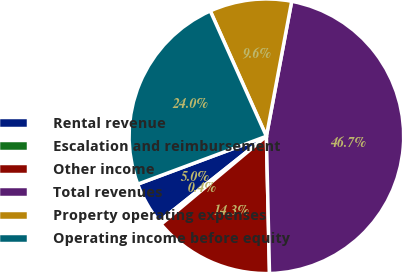Convert chart to OTSL. <chart><loc_0><loc_0><loc_500><loc_500><pie_chart><fcel>Rental revenue<fcel>Escalation and reimbursement<fcel>Other income<fcel>Total revenues<fcel>Property operating expenses<fcel>Operating income before equity<nl><fcel>5.02%<fcel>0.39%<fcel>14.28%<fcel>46.69%<fcel>9.65%<fcel>23.97%<nl></chart> 